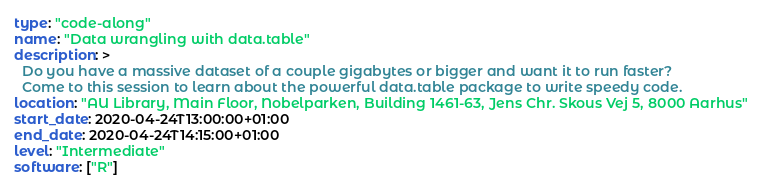<code> <loc_0><loc_0><loc_500><loc_500><_YAML_>type: "code-along"
name: "Data wrangling with data.table"
description: >
  Do you have a massive dataset of a couple gigabytes or bigger and want it to run faster?
  Come to this session to learn about the powerful data.table package to write speedy code.
location: "AU Library, Main Floor, Nobelparken, Building 1461-63, Jens Chr. Skous Vej 5, 8000 Aarhus"
start_date: 2020-04-24T13:00:00+01:00
end_date: 2020-04-24T14:15:00+01:00
level: "Intermediate"
software: ["R"]
</code> 